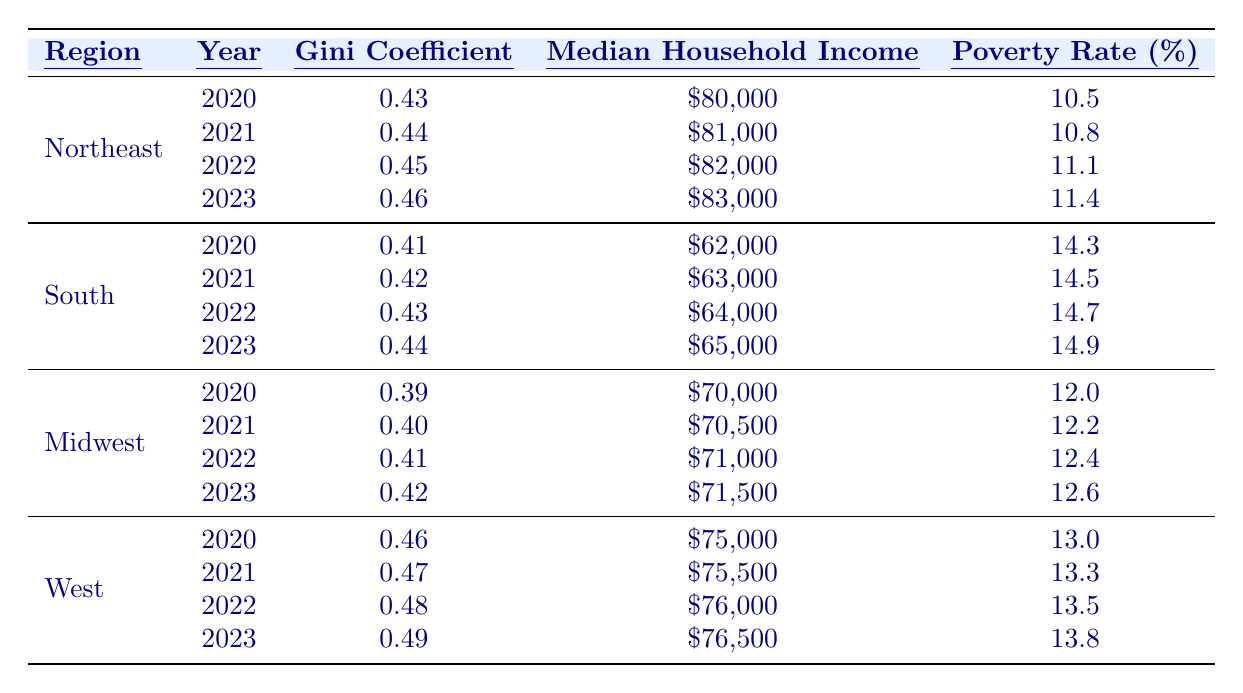What was the Gini coefficient in the South in 2022? From the table, the Gini coefficient for the South in 2022 is specifically listed as 0.43
Answer: 0.43 What is the median household income in the Northeast for 2023? The median household income for the Northeast in 2023 is directly provided in the table as $83,000
Answer: $83,000 Which region had the highest poverty rate in 2021? In 2021, the South had a poverty rate of 14.5%, which is higher than the rates of 10.8% in the Northeast, 12.2% in the Midwest, and 13.3% in the West
Answer: South What is the difference in the Gini coefficient between the West in 2020 and the West in 2023? The Gini coefficient for the West in 2020 is 0.46, and in 2023 it is 0.49. The difference is 0.49 - 0.46 = 0.03
Answer: 0.03 What was the average poverty rate across all regions in 2022? The poverty rates in 2022 were 11.1% (Northeast), 14.7% (South), 12.4% (Midwest), and 13.5% (West). Summing them gives 11.1 + 14.7 + 12.4 + 13.5 = 51.7%. Dividing by 4 (the number of regions) gives an average of 51.7/4 = 12.925%. When rounded, this is approximately 12.93%
Answer: 12.93% Did the median household income in the Midwest increase every year from 2020 to 2023? Analyzing the data: in 2020 it was $70,000, 2021 it was $70,500, 2022 it was $71,000, and 2023 it was $71,500. All values show a consistent increase each year
Answer: Yes What is the percentage of wealth held by the top 10% in the West in 2023? The wealth distribution indicates that the top 10% in the West held 46% of the wealth in 2023, as shown directly in the table
Answer: 46% In which region and year did the median household income first exceed $80,000? The first instance when the median household income exceeds $80,000 in the data is in the Northeast for the year 2021, where it is $81,000
Answer: Northeast, 2021 What is the change in wealth distribution for the bottom 90% in the Midwest from 2020 to 2023? In 2020, the bottom 90% in the Midwest held 65%, and in 2023 they held 62%. The change is calculated as 65% - 62% = 3%
Answer: 3% decrease 